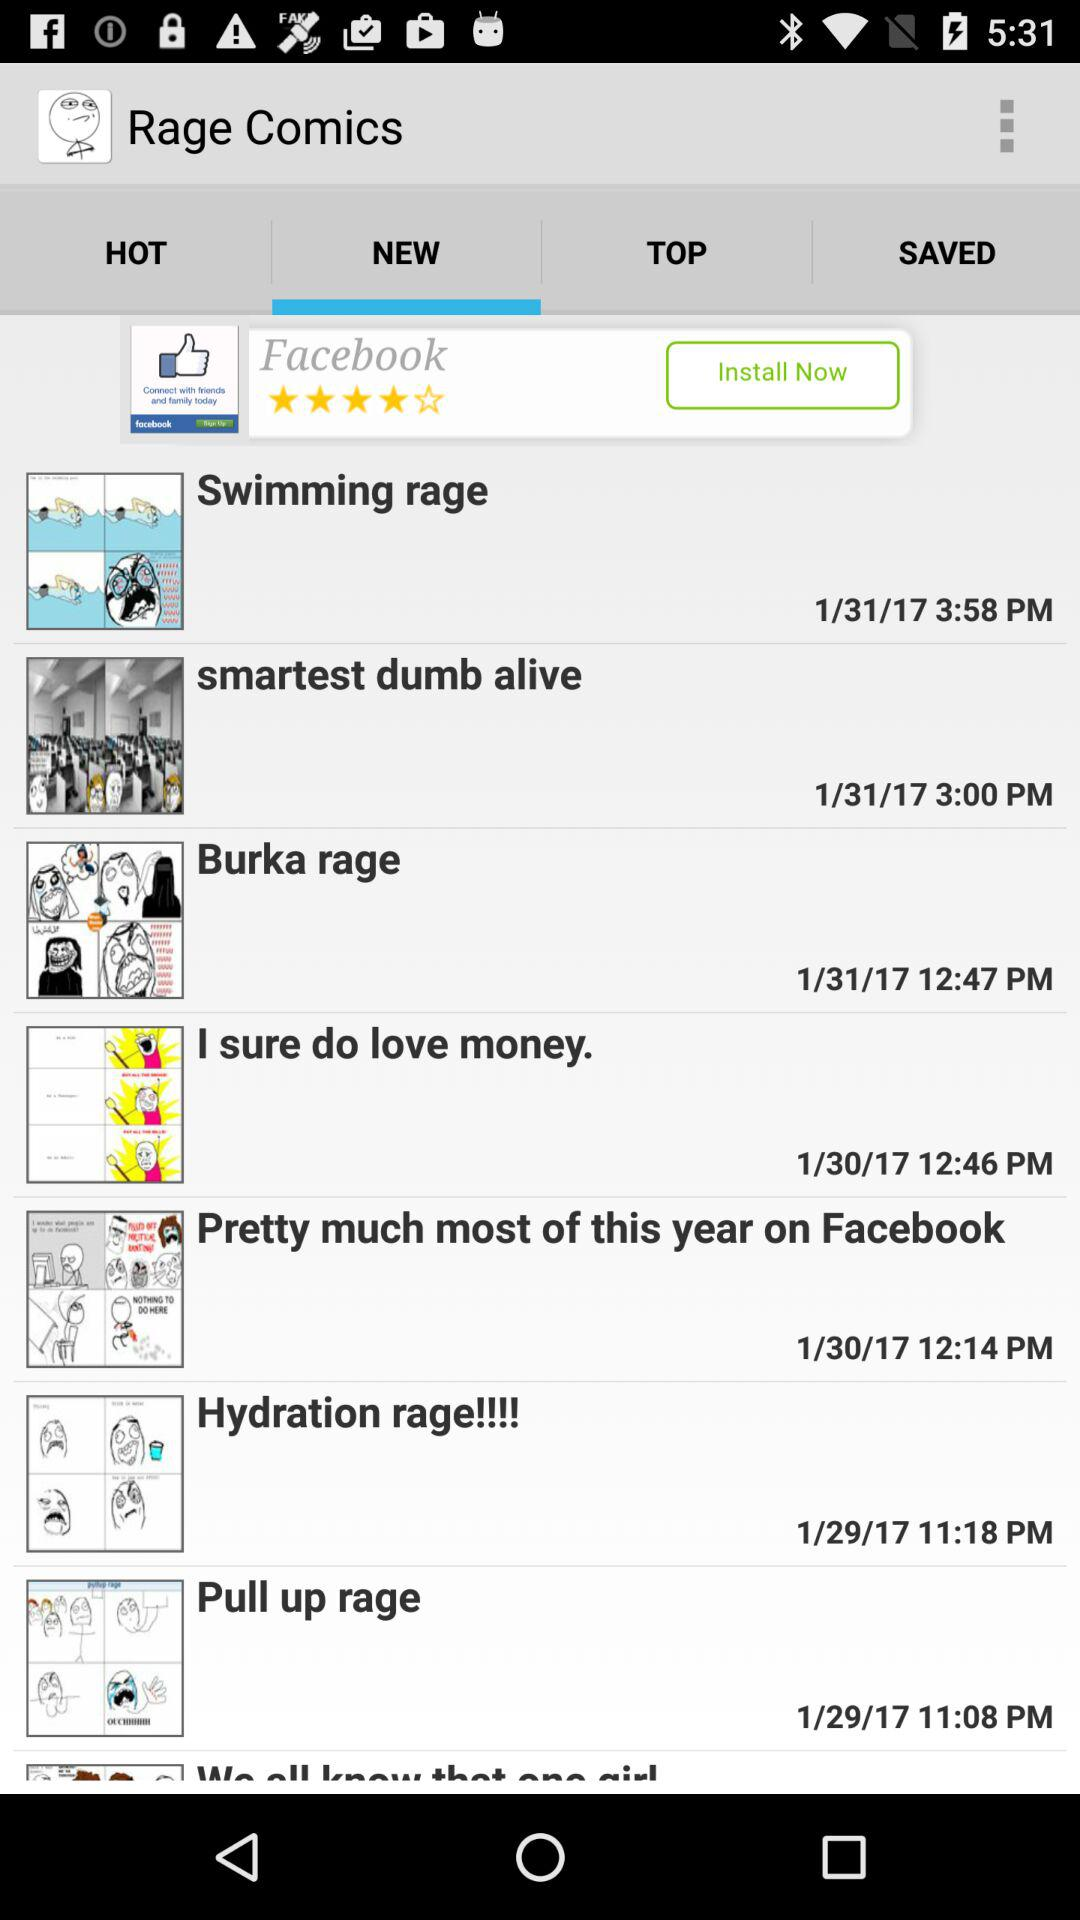What is the date and time of the swimming rage? The date is 1/31/17 and the time is 3:58 PM. 